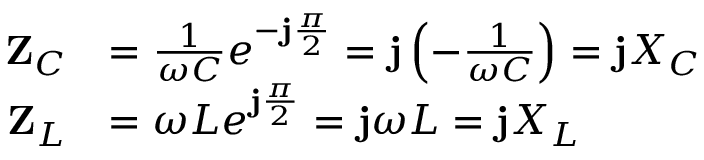<formula> <loc_0><loc_0><loc_500><loc_500>{ \begin{array} { r l } { Z _ { C } } & { = { \frac { 1 } { \omega C } } e ^ { - j { \frac { \pi } { 2 } } } = j \left ( { - { \frac { 1 } { \omega C } } } \right ) = j X _ { C } } \\ { Z _ { L } } & { = \omega L e ^ { j { \frac { \pi } { 2 } } } = j \omega L = j X _ { L } \quad } \end{array} }</formula> 